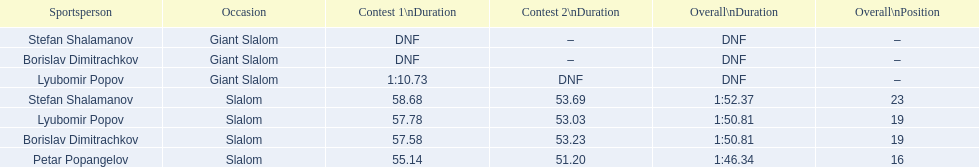Which event is the giant slalom? Giant Slalom, Giant Slalom, Giant Slalom. Which one is lyubomir popov? Lyubomir Popov. What is race 1 tim? 1:10.73. 